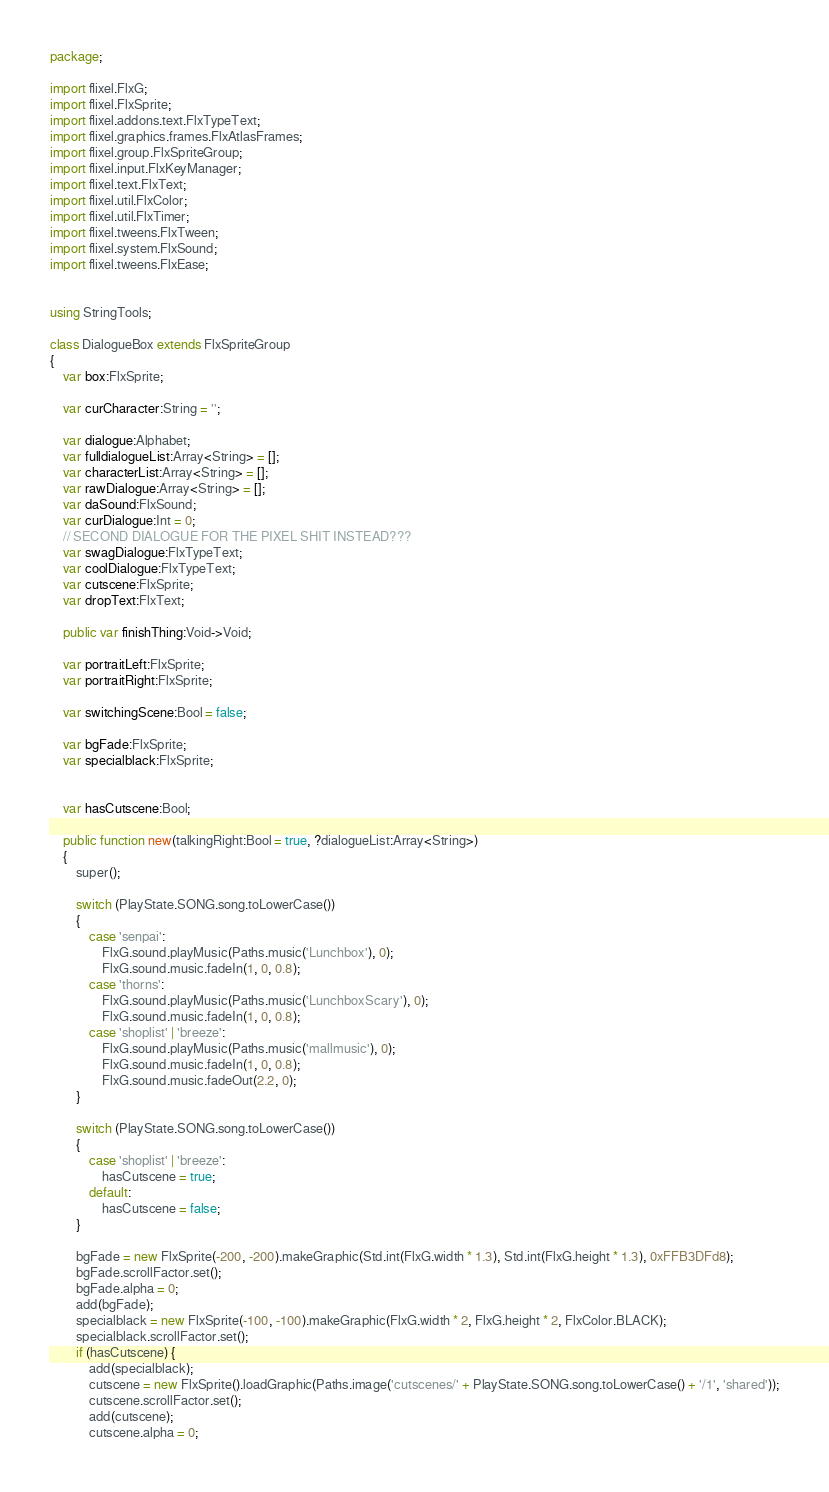<code> <loc_0><loc_0><loc_500><loc_500><_Haxe_>package;

import flixel.FlxG;
import flixel.FlxSprite;
import flixel.addons.text.FlxTypeText;
import flixel.graphics.frames.FlxAtlasFrames;
import flixel.group.FlxSpriteGroup;
import flixel.input.FlxKeyManager;
import flixel.text.FlxText;
import flixel.util.FlxColor;
import flixel.util.FlxTimer;
import flixel.tweens.FlxTween;
import flixel.system.FlxSound;
import flixel.tweens.FlxEase;


using StringTools;

class DialogueBox extends FlxSpriteGroup
{
	var box:FlxSprite;

	var curCharacter:String = '';

	var dialogue:Alphabet;
	var fulldialogueList:Array<String> = [];
	var characterList:Array<String> = [];
	var rawDialogue:Array<String> = [];
	var daSound:FlxSound;
	var curDialogue:Int = 0;
	// SECOND DIALOGUE FOR THE PIXEL SHIT INSTEAD???
	var swagDialogue:FlxTypeText;
	var coolDialogue:FlxTypeText;
	var cutscene:FlxSprite;
	var dropText:FlxText;

	public var finishThing:Void->Void;

	var portraitLeft:FlxSprite;
	var portraitRight:FlxSprite;

	var switchingScene:Bool = false;

	var bgFade:FlxSprite;
	var specialblack:FlxSprite;
	

	var hasCutscene:Bool;

	public function new(talkingRight:Bool = true, ?dialogueList:Array<String>)
	{
		super();

		switch (PlayState.SONG.song.toLowerCase())
		{
			case 'senpai':
				FlxG.sound.playMusic(Paths.music('Lunchbox'), 0);
				FlxG.sound.music.fadeIn(1, 0, 0.8);
			case 'thorns':
				FlxG.sound.playMusic(Paths.music('LunchboxScary'), 0);
				FlxG.sound.music.fadeIn(1, 0, 0.8);
			case 'shoplist' | 'breeze':
				FlxG.sound.playMusic(Paths.music('mallmusic'), 0);
				FlxG.sound.music.fadeIn(1, 0, 0.8);
				FlxG.sound.music.fadeOut(2.2, 0);
		}

		switch (PlayState.SONG.song.toLowerCase())
		{
			case 'shoplist' | 'breeze':
				hasCutscene = true;
			default:
				hasCutscene = false;
		}
		
		bgFade = new FlxSprite(-200, -200).makeGraphic(Std.int(FlxG.width * 1.3), Std.int(FlxG.height * 1.3), 0xFFB3DFd8);
		bgFade.scrollFactor.set();
		bgFade.alpha = 0;
		add(bgFade);
		specialblack = new FlxSprite(-100, -100).makeGraphic(FlxG.width * 2, FlxG.height * 2, FlxColor.BLACK);
		specialblack.scrollFactor.set();
		if (hasCutscene) {
			add(specialblack);
			cutscene = new FlxSprite().loadGraphic(Paths.image('cutscenes/' + PlayState.SONG.song.toLowerCase() + '/1', 'shared'));
			cutscene.scrollFactor.set();
			add(cutscene);
			cutscene.alpha = 0;</code> 